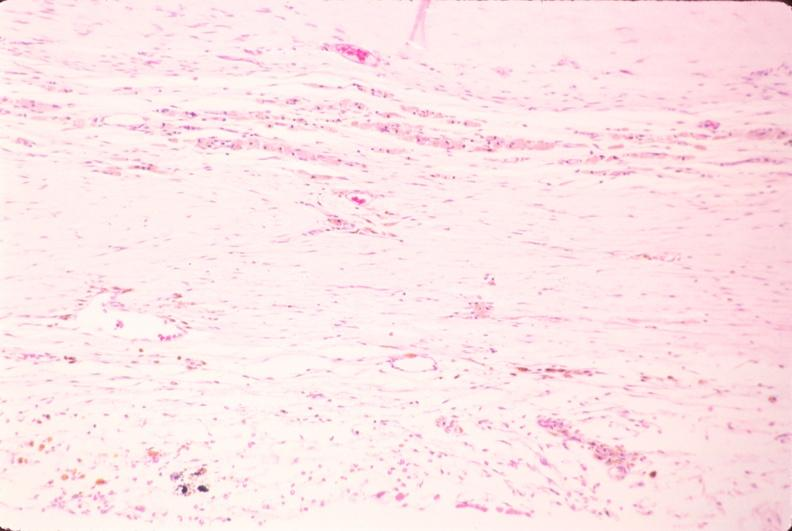s nervous present?
Answer the question using a single word or phrase. Yes 